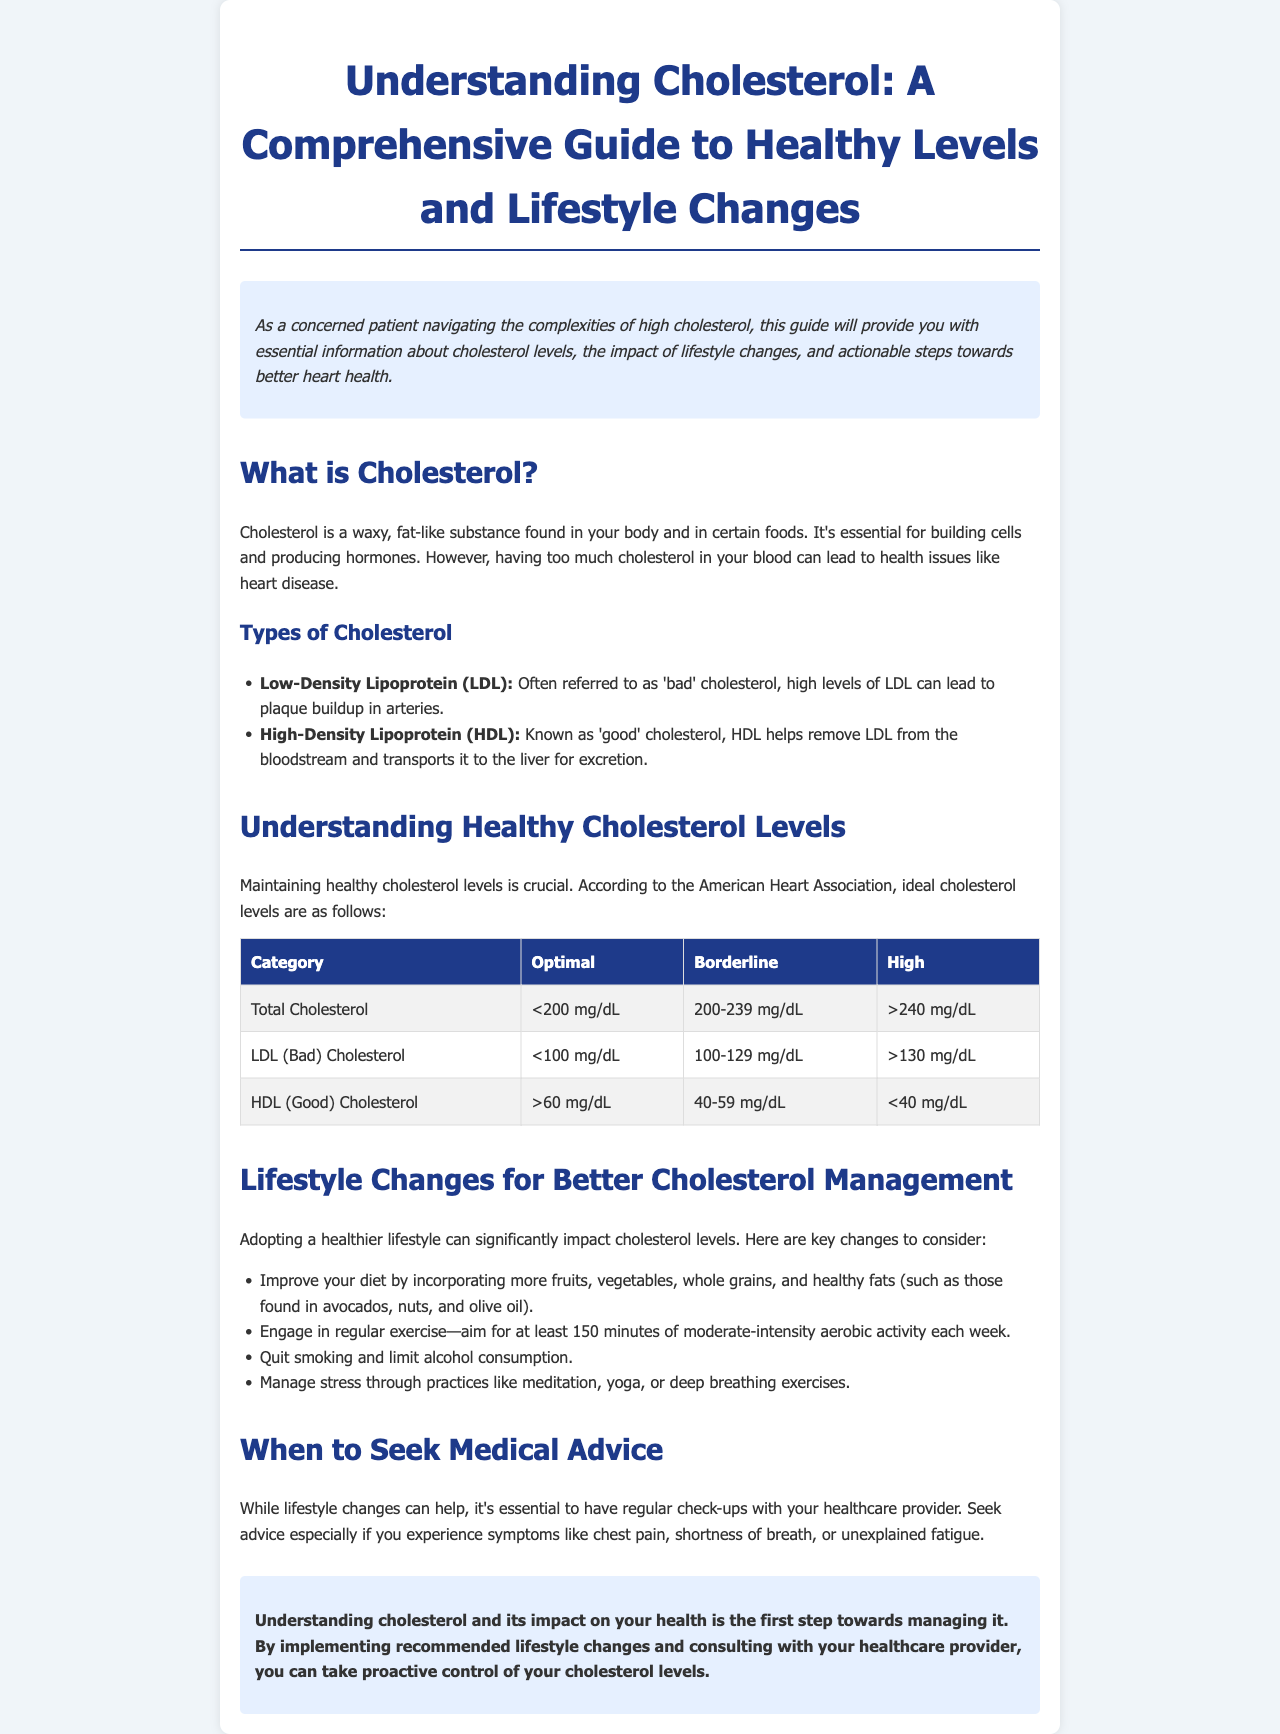What is cholesterol? Cholesterol is a waxy, fat-like substance found in your body and in certain foods, essential for building cells and producing hormones.
Answer: A waxy, fat-like substance What is considered high total cholesterol? According to the document, high total cholesterol is defined as greater than 240 mg/dL.
Answer: Greater than 240 mg/dL What is the optimal level for LDL cholesterol? The document states that the optimal level for LDL cholesterol is less than 100 mg/dL.
Answer: Less than 100 mg/dL List one lifestyle change to manage cholesterol. The document suggests improving your diet by incorporating more fruits, vegetables, whole grains, and healthy fats.
Answer: Improve your diet When should you seek medical advice related to cholesterol? It's essential to seek medical advice when experiencing symptoms like chest pain or shortness of breath.
Answer: Chest pain or shortness of breath What type of cholesterol is known as 'good' cholesterol? The document indicates that High-Density Lipoprotein (HDL) is known as 'good' cholesterol.
Answer: High-Density Lipoprotein (HDL) What is the optimal HDL level? The optimal HDL level is defined as greater than 60 mg/dL according to the American Heart Association.
Answer: Greater than 60 mg/dL How many minutes of exercise should one aim for each week? The document recommends aiming for at least 150 minutes of moderate-intensity aerobic activity each week.
Answer: At least 150 minutes What color is used for the introduction section? The introduction section has a background color described as light blue.
Answer: Light blue 